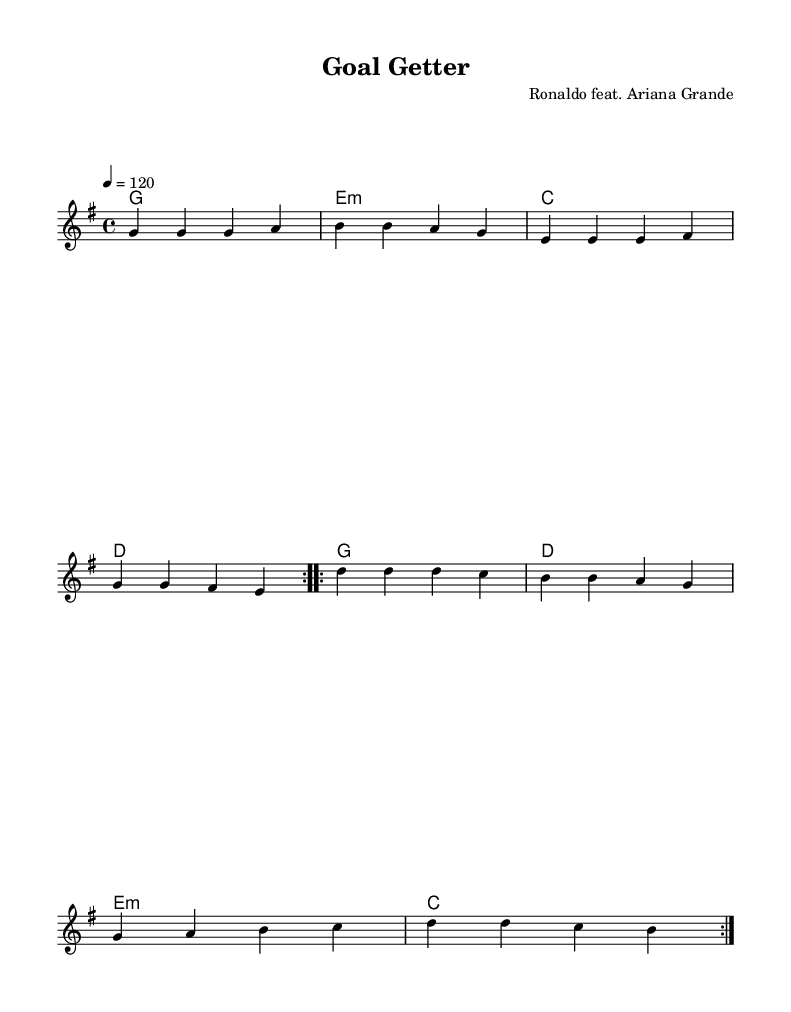what is the key signature of this music? The key signature is indicated at the beginning of the staff, showing one sharp (F#), which means it is in G major.
Answer: G major what is the time signature of this music? The time signature is found at the beginning of the score, showing a "4/4" symbol, which means there are four beats in each measure.
Answer: 4/4 what is the tempo marking of this piece? The tempo marking is indicated at the start of the score, which states "4 = 120", meaning there are 120 beats per minute.
Answer: 120 how many times is the first section repeated? The repeat instructions in the sheet music state that the first section (with the melody) is repeated "volta 2", meaning it is played twice.
Answer: 2 who are the featured artists of this song? The composer's name given in the header specifies "Ronaldo feat. Ariana Grande," indicating the artists involved in this collaboration.
Answer: Ronaldo feat. Ariana Grande what is the first lyric of the song? The lyrics are provided below the melody, and the first line reads "On the field, I'm in control."
Answer: On the field, I'm in control what genre does this piece belong to? This piece is labeled as "Pop" in the context of modern music collaborations, emphasizing upbeat and catchy melodies typical of pop songs.
Answer: Pop 